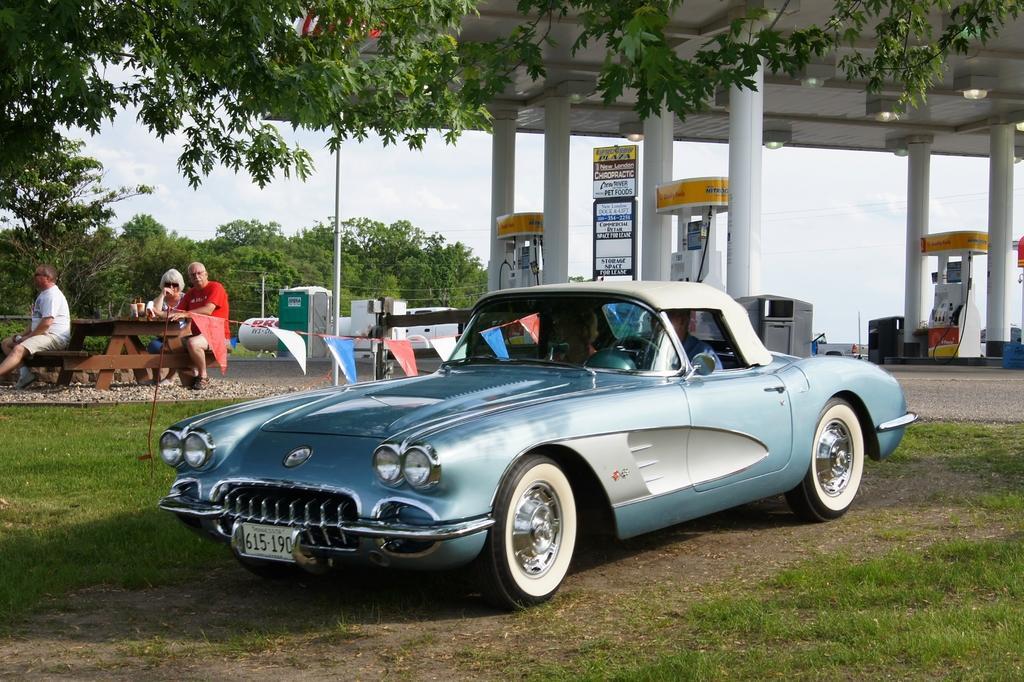Could you give a brief overview of what you see in this image? In the middle of the picture, we see a blue color car. Beside that, there are flags in white, red and blue color. Beside that, there are three people sitting on the bench. Behind them, we see a petrol pump and pillars. We even see a board with some text written on it. There are trees in the background. At the bottom of the picture, we see grass. 